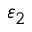<formula> <loc_0><loc_0><loc_500><loc_500>\varepsilon _ { 2 }</formula> 